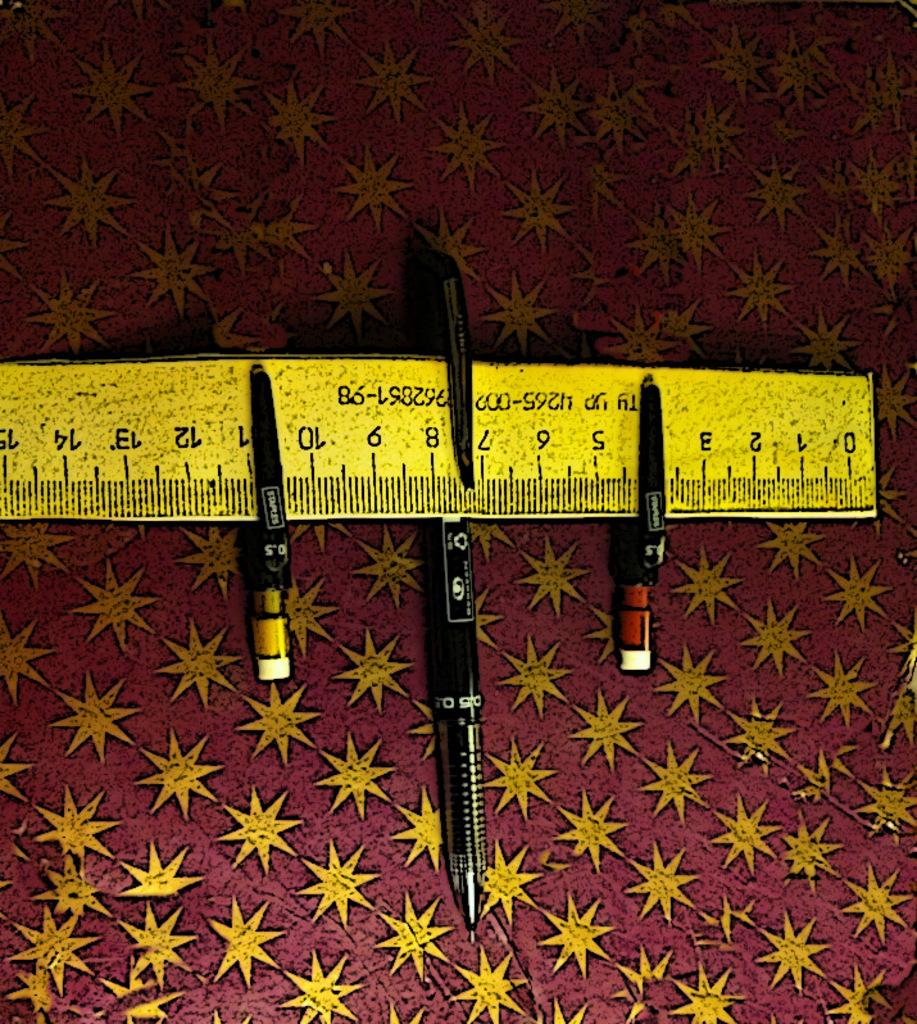<image>
Describe the image concisely. a yellow ruler with letters Ty yp on it 